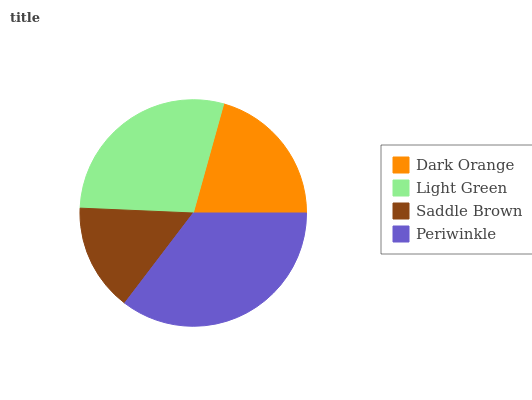Is Saddle Brown the minimum?
Answer yes or no. Yes. Is Periwinkle the maximum?
Answer yes or no. Yes. Is Light Green the minimum?
Answer yes or no. No. Is Light Green the maximum?
Answer yes or no. No. Is Light Green greater than Dark Orange?
Answer yes or no. Yes. Is Dark Orange less than Light Green?
Answer yes or no. Yes. Is Dark Orange greater than Light Green?
Answer yes or no. No. Is Light Green less than Dark Orange?
Answer yes or no. No. Is Light Green the high median?
Answer yes or no. Yes. Is Dark Orange the low median?
Answer yes or no. Yes. Is Saddle Brown the high median?
Answer yes or no. No. Is Saddle Brown the low median?
Answer yes or no. No. 